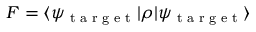<formula> <loc_0><loc_0><loc_500><loc_500>F = \langle \psi _ { t \arg e t } | \rho | \psi _ { t \arg e t } \rangle</formula> 